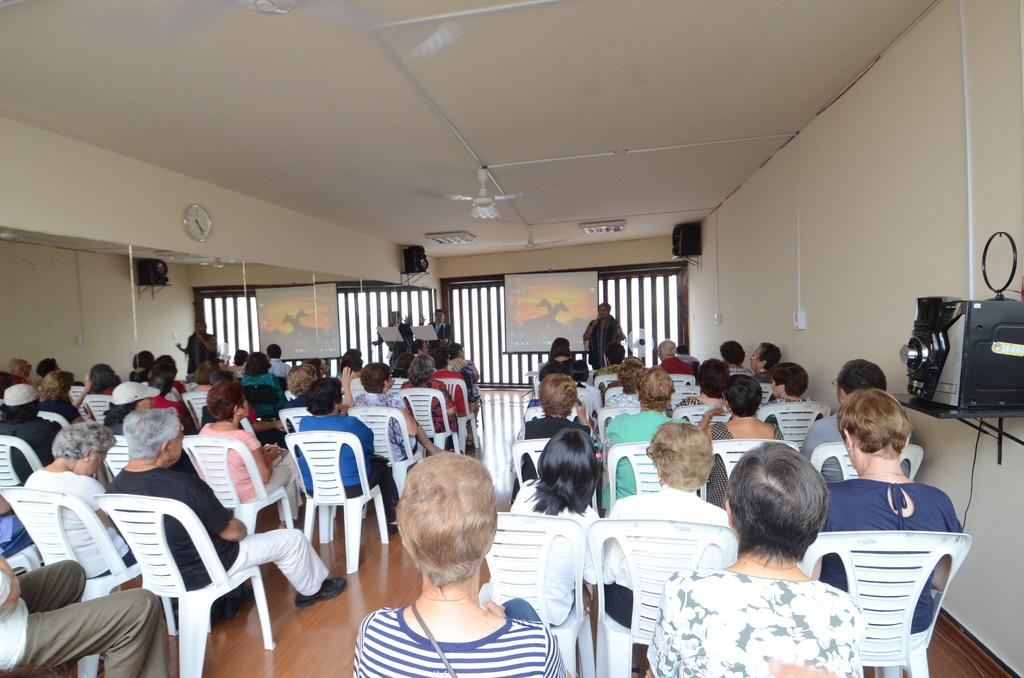What are the people in the image doing? There is a group of people sitting on chairs, and three persons are standing on stage. What can be seen on the stage? There are three persons standing on stage. What is present in the image that might be used for displaying information or visuals? There is a screen in the image. What architectural feature is visible in the image? There is a wall in the image. What devices are present in the image that might be used for amplifying sound? There are speakers in the image. What appliance is present in the image that might be used for cooling the room? There is a fan in the image. What object is present in the image that might be used for telling time? There is a clock in the image. What type of servant is standing next to the clock in the image? There is no servant present in the image; it features a group of people sitting on chairs and three persons standing on stage. What type of haircut is being given to the person in the image? There is no haircut being given in the image; it features a group of people sitting on chairs and three persons standing on stage. 